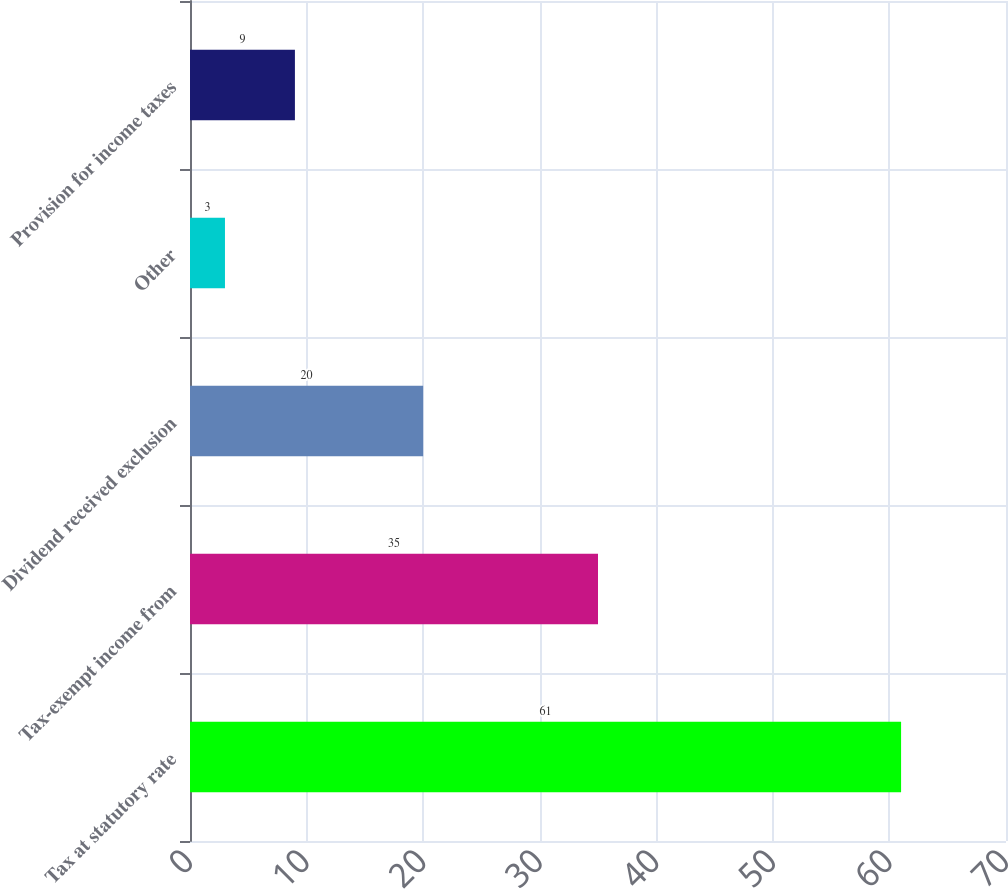Convert chart. <chart><loc_0><loc_0><loc_500><loc_500><bar_chart><fcel>Tax at statutory rate<fcel>Tax-exempt income from<fcel>Dividend received exclusion<fcel>Other<fcel>Provision for income taxes<nl><fcel>61<fcel>35<fcel>20<fcel>3<fcel>9<nl></chart> 